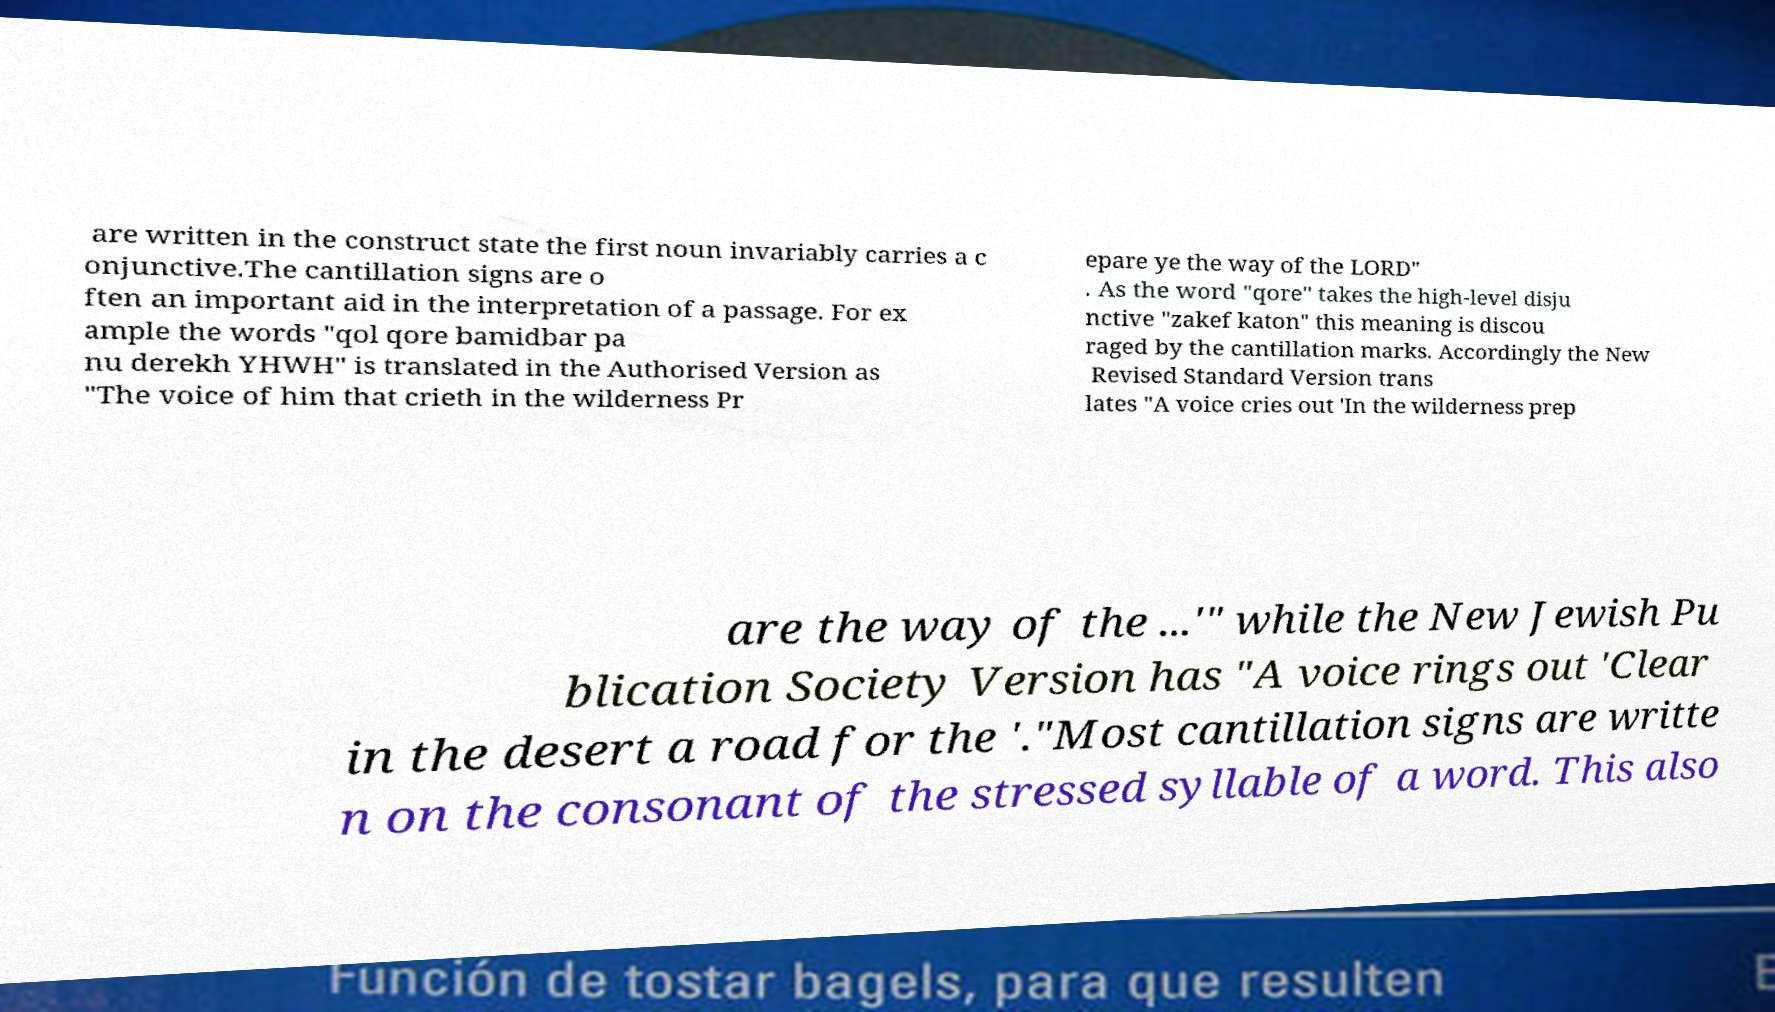For documentation purposes, I need the text within this image transcribed. Could you provide that? are written in the construct state the first noun invariably carries a c onjunctive.The cantillation signs are o ften an important aid in the interpretation of a passage. For ex ample the words "qol qore bamidbar pa nu derekh YHWH" is translated in the Authorised Version as "The voice of him that crieth in the wilderness Pr epare ye the way of the LORD" . As the word "qore" takes the high-level disju nctive "zakef katon" this meaning is discou raged by the cantillation marks. Accordingly the New Revised Standard Version trans lates "A voice cries out 'In the wilderness prep are the way of the ...'" while the New Jewish Pu blication Society Version has "A voice rings out 'Clear in the desert a road for the '."Most cantillation signs are writte n on the consonant of the stressed syllable of a word. This also 